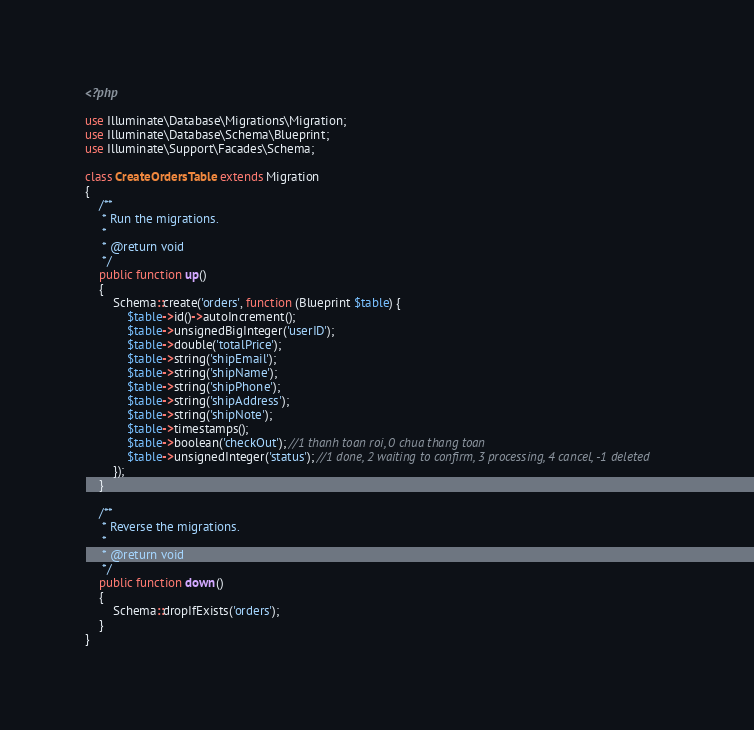<code> <loc_0><loc_0><loc_500><loc_500><_PHP_><?php

use Illuminate\Database\Migrations\Migration;
use Illuminate\Database\Schema\Blueprint;
use Illuminate\Support\Facades\Schema;

class CreateOrdersTable extends Migration
{
    /**
     * Run the migrations.
     *
     * @return void
     */
    public function up()
    {
        Schema::create('orders', function (Blueprint $table) {
            $table->id()->autoIncrement();
            $table->unsignedBigInteger('userID');
            $table->double('totalPrice');
            $table->string('shipEmail');
            $table->string('shipName');
            $table->string('shipPhone');
            $table->string('shipAddress');
            $table->string('shipNote');
            $table->timestamps();
            $table->boolean('checkOut'); //1 thanh toan roi, 0 chua thang toan
            $table->unsignedInteger('status'); //1 done, 2 waiting to confirm, 3 processing, 4 cancel, -1 deleted
        });
    }

    /**
     * Reverse the migrations.
     *
     * @return void
     */
    public function down()
    {
        Schema::dropIfExists('orders');
    }
}
</code> 